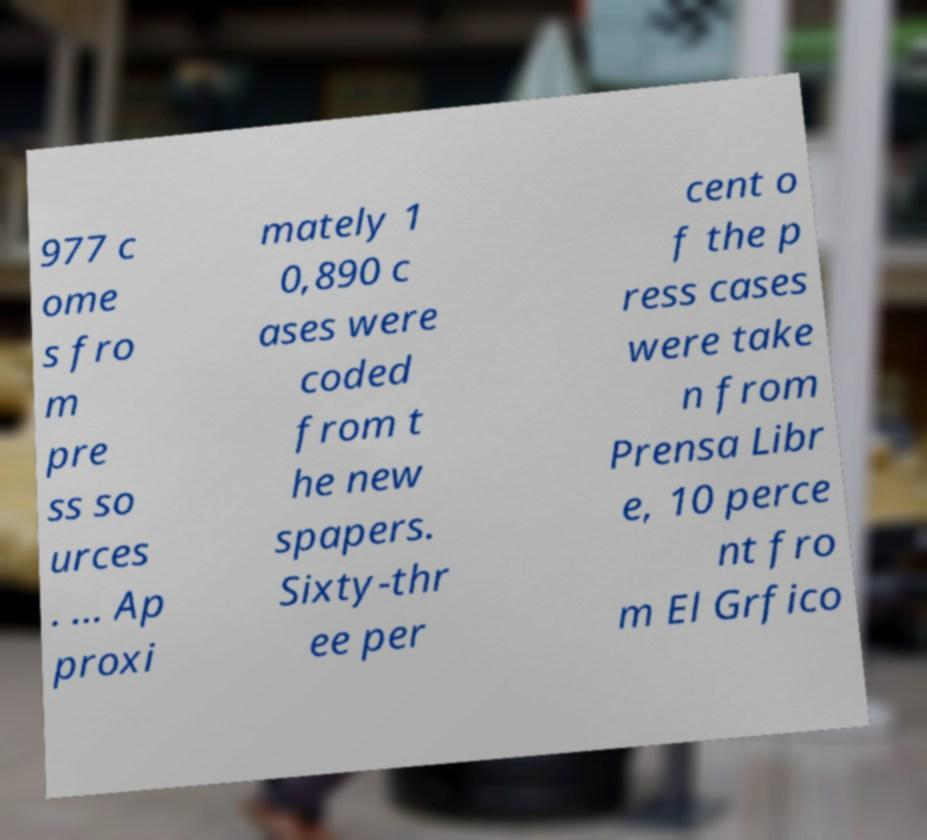I need the written content from this picture converted into text. Can you do that? 977 c ome s fro m pre ss so urces . ... Ap proxi mately 1 0,890 c ases were coded from t he new spapers. Sixty-thr ee per cent o f the p ress cases were take n from Prensa Libr e, 10 perce nt fro m El Grfico 